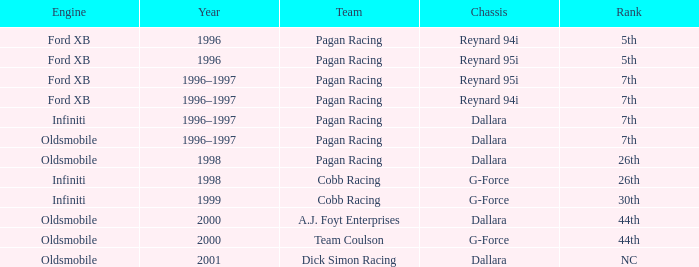What motor was utilized in 1999? Infiniti. 